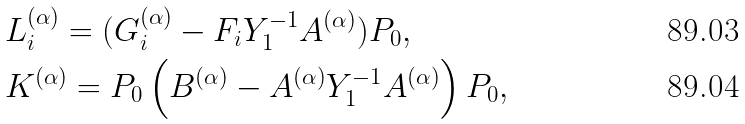Convert formula to latex. <formula><loc_0><loc_0><loc_500><loc_500>& L _ { i } ^ { ( \alpha ) } = ( G _ { i } ^ { ( \alpha ) } - F _ { i } Y ^ { - 1 } _ { 1 } A ^ { ( \alpha ) } ) P _ { 0 } , \\ & K ^ { ( \alpha ) } = P _ { 0 } \left ( B ^ { ( \alpha ) } - A ^ { ( \alpha ) } Y _ { 1 } ^ { - 1 } A ^ { ( \alpha ) } \right ) P _ { 0 } ,</formula> 